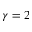Convert formula to latex. <formula><loc_0><loc_0><loc_500><loc_500>\gamma = 2</formula> 